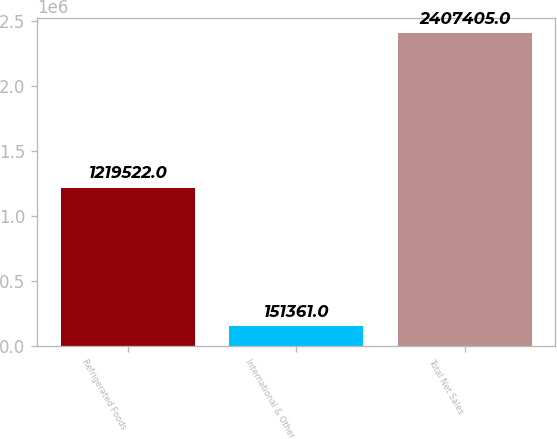Convert chart. <chart><loc_0><loc_0><loc_500><loc_500><bar_chart><fcel>Refrigerated Foods<fcel>International & Other<fcel>Total Net Sales<nl><fcel>1.21952e+06<fcel>151361<fcel>2.4074e+06<nl></chart> 